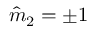<formula> <loc_0><loc_0><loc_500><loc_500>\hat { m } _ { 2 } = \pm 1</formula> 